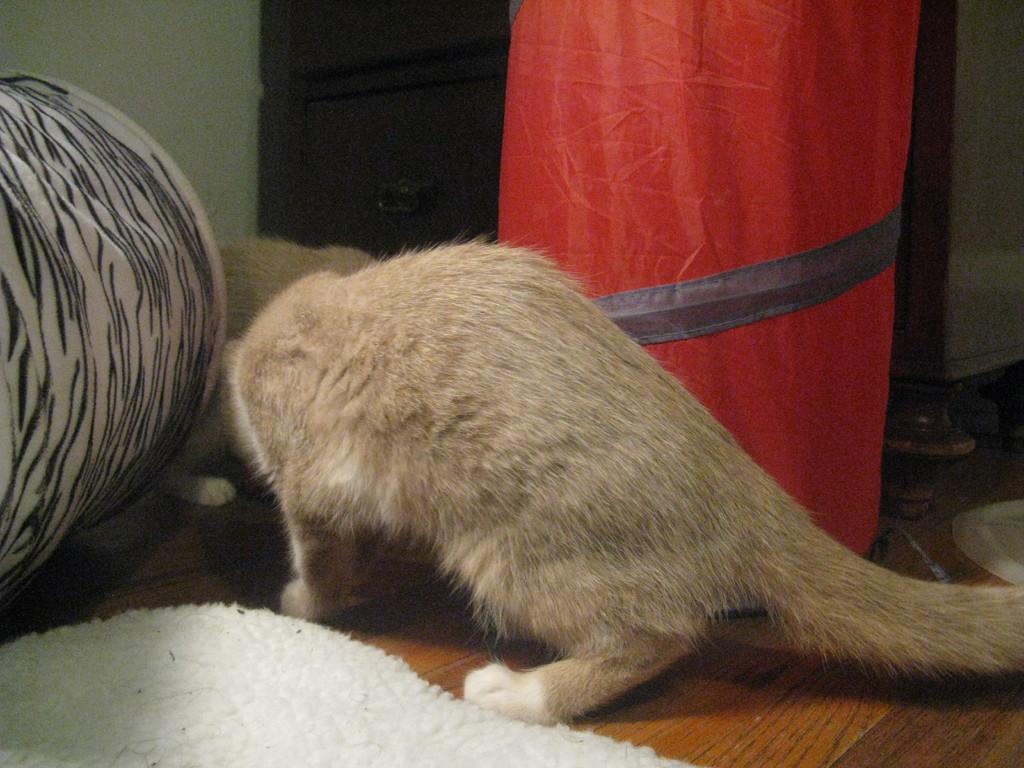How would you summarize this image in a sentence or two? In this picture I can see couple of cats and baskets and I can see a carpet on the floor, looks like few footwear on the right side. 